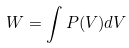Convert formula to latex. <formula><loc_0><loc_0><loc_500><loc_500>W = \int P ( V ) d V</formula> 